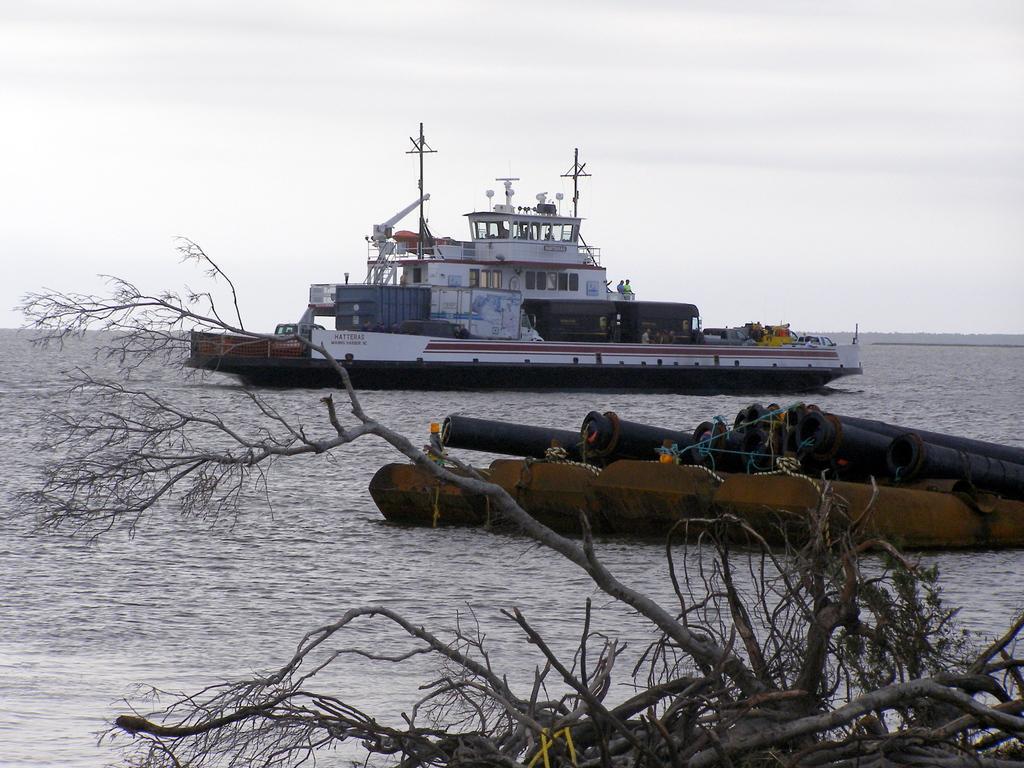In one or two sentences, can you explain what this image depicts? This image consists of a ship. At the bottom, there is water. And we can see dried plants. In the middle, there are pipes. 